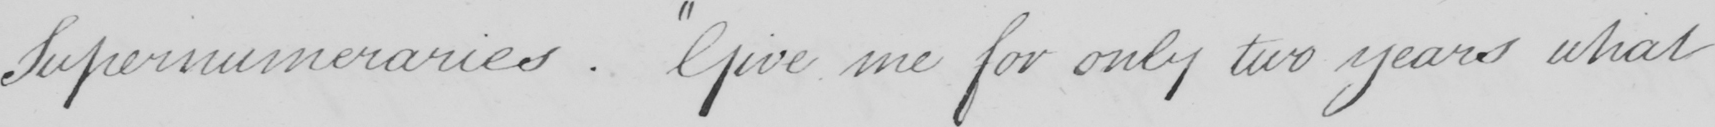What text is written in this handwritten line? Supernumeraries .  " Give me for only two years what 